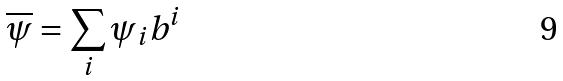<formula> <loc_0><loc_0><loc_500><loc_500>\overline { \psi } = \sum _ { i } \psi _ { i } b ^ { i }</formula> 